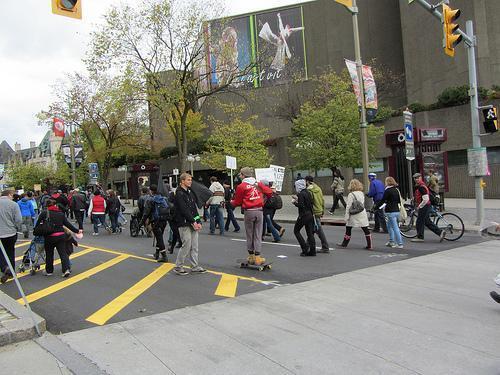How many bikes are there?
Give a very brief answer. 1. 